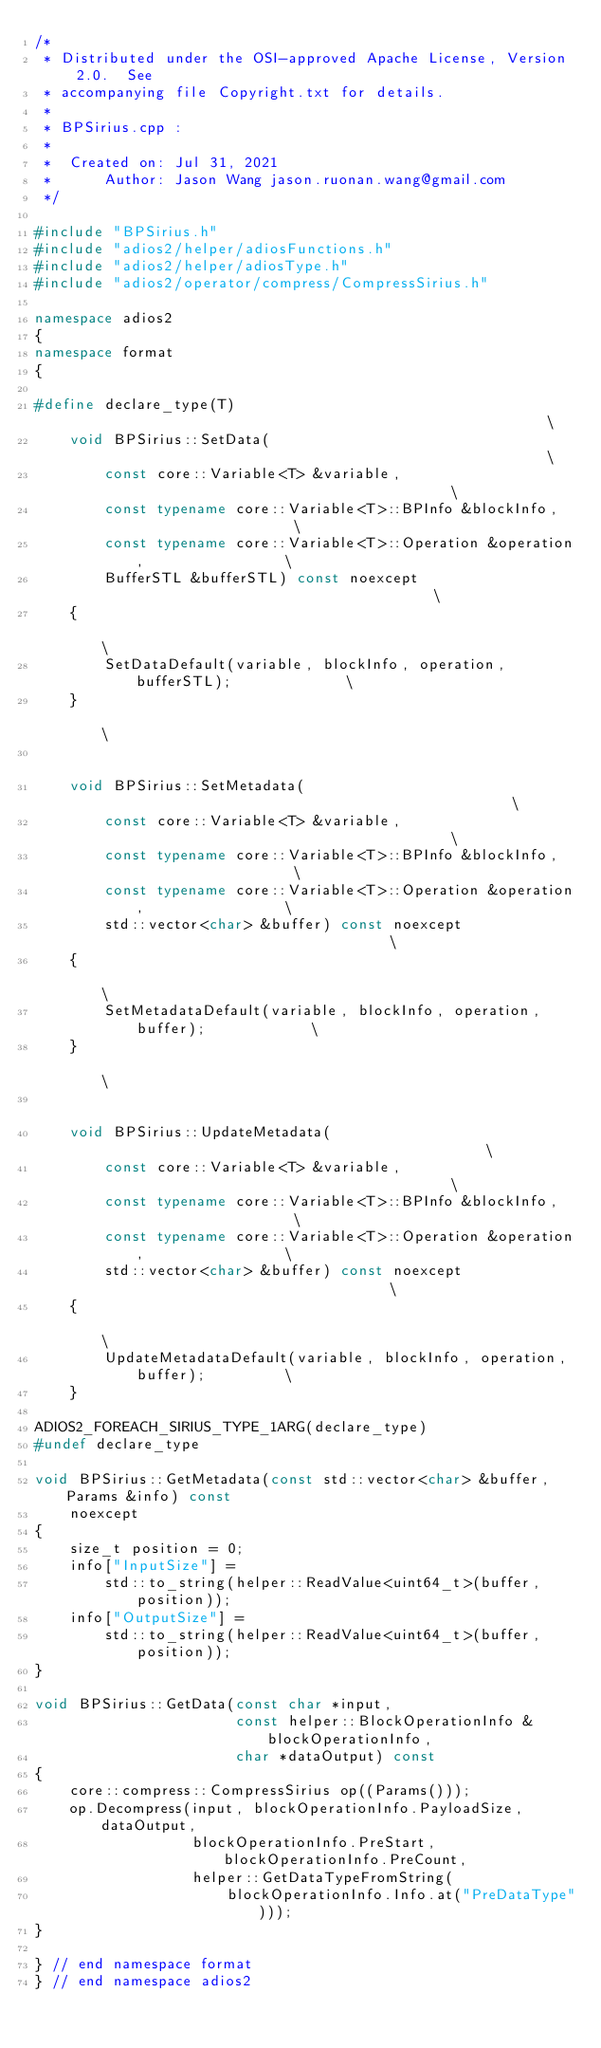<code> <loc_0><loc_0><loc_500><loc_500><_C++_>/*
 * Distributed under the OSI-approved Apache License, Version 2.0.  See
 * accompanying file Copyright.txt for details.
 *
 * BPSirius.cpp :
 *
 *  Created on: Jul 31, 2021
 *      Author: Jason Wang jason.ruonan.wang@gmail.com
 */

#include "BPSirius.h"
#include "adios2/helper/adiosFunctions.h"
#include "adios2/helper/adiosType.h"
#include "adios2/operator/compress/CompressSirius.h"

namespace adios2
{
namespace format
{

#define declare_type(T)                                                        \
    void BPSirius::SetData(                                                    \
        const core::Variable<T> &variable,                                     \
        const typename core::Variable<T>::BPInfo &blockInfo,                   \
        const typename core::Variable<T>::Operation &operation,                \
        BufferSTL &bufferSTL) const noexcept                                   \
    {                                                                          \
        SetDataDefault(variable, blockInfo, operation, bufferSTL);             \
    }                                                                          \
                                                                               \
    void BPSirius::SetMetadata(                                                \
        const core::Variable<T> &variable,                                     \
        const typename core::Variable<T>::BPInfo &blockInfo,                   \
        const typename core::Variable<T>::Operation &operation,                \
        std::vector<char> &buffer) const noexcept                              \
    {                                                                          \
        SetMetadataDefault(variable, blockInfo, operation, buffer);            \
    }                                                                          \
                                                                               \
    void BPSirius::UpdateMetadata(                                             \
        const core::Variable<T> &variable,                                     \
        const typename core::Variable<T>::BPInfo &blockInfo,                   \
        const typename core::Variable<T>::Operation &operation,                \
        std::vector<char> &buffer) const noexcept                              \
    {                                                                          \
        UpdateMetadataDefault(variable, blockInfo, operation, buffer);         \
    }

ADIOS2_FOREACH_SIRIUS_TYPE_1ARG(declare_type)
#undef declare_type

void BPSirius::GetMetadata(const std::vector<char> &buffer, Params &info) const
    noexcept
{
    size_t position = 0;
    info["InputSize"] =
        std::to_string(helper::ReadValue<uint64_t>(buffer, position));
    info["OutputSize"] =
        std::to_string(helper::ReadValue<uint64_t>(buffer, position));
}

void BPSirius::GetData(const char *input,
                       const helper::BlockOperationInfo &blockOperationInfo,
                       char *dataOutput) const
{
    core::compress::CompressSirius op((Params()));
    op.Decompress(input, blockOperationInfo.PayloadSize, dataOutput,
                  blockOperationInfo.PreStart, blockOperationInfo.PreCount,
                  helper::GetDataTypeFromString(
                      blockOperationInfo.Info.at("PreDataType")));
}

} // end namespace format
} // end namespace adios2
</code> 